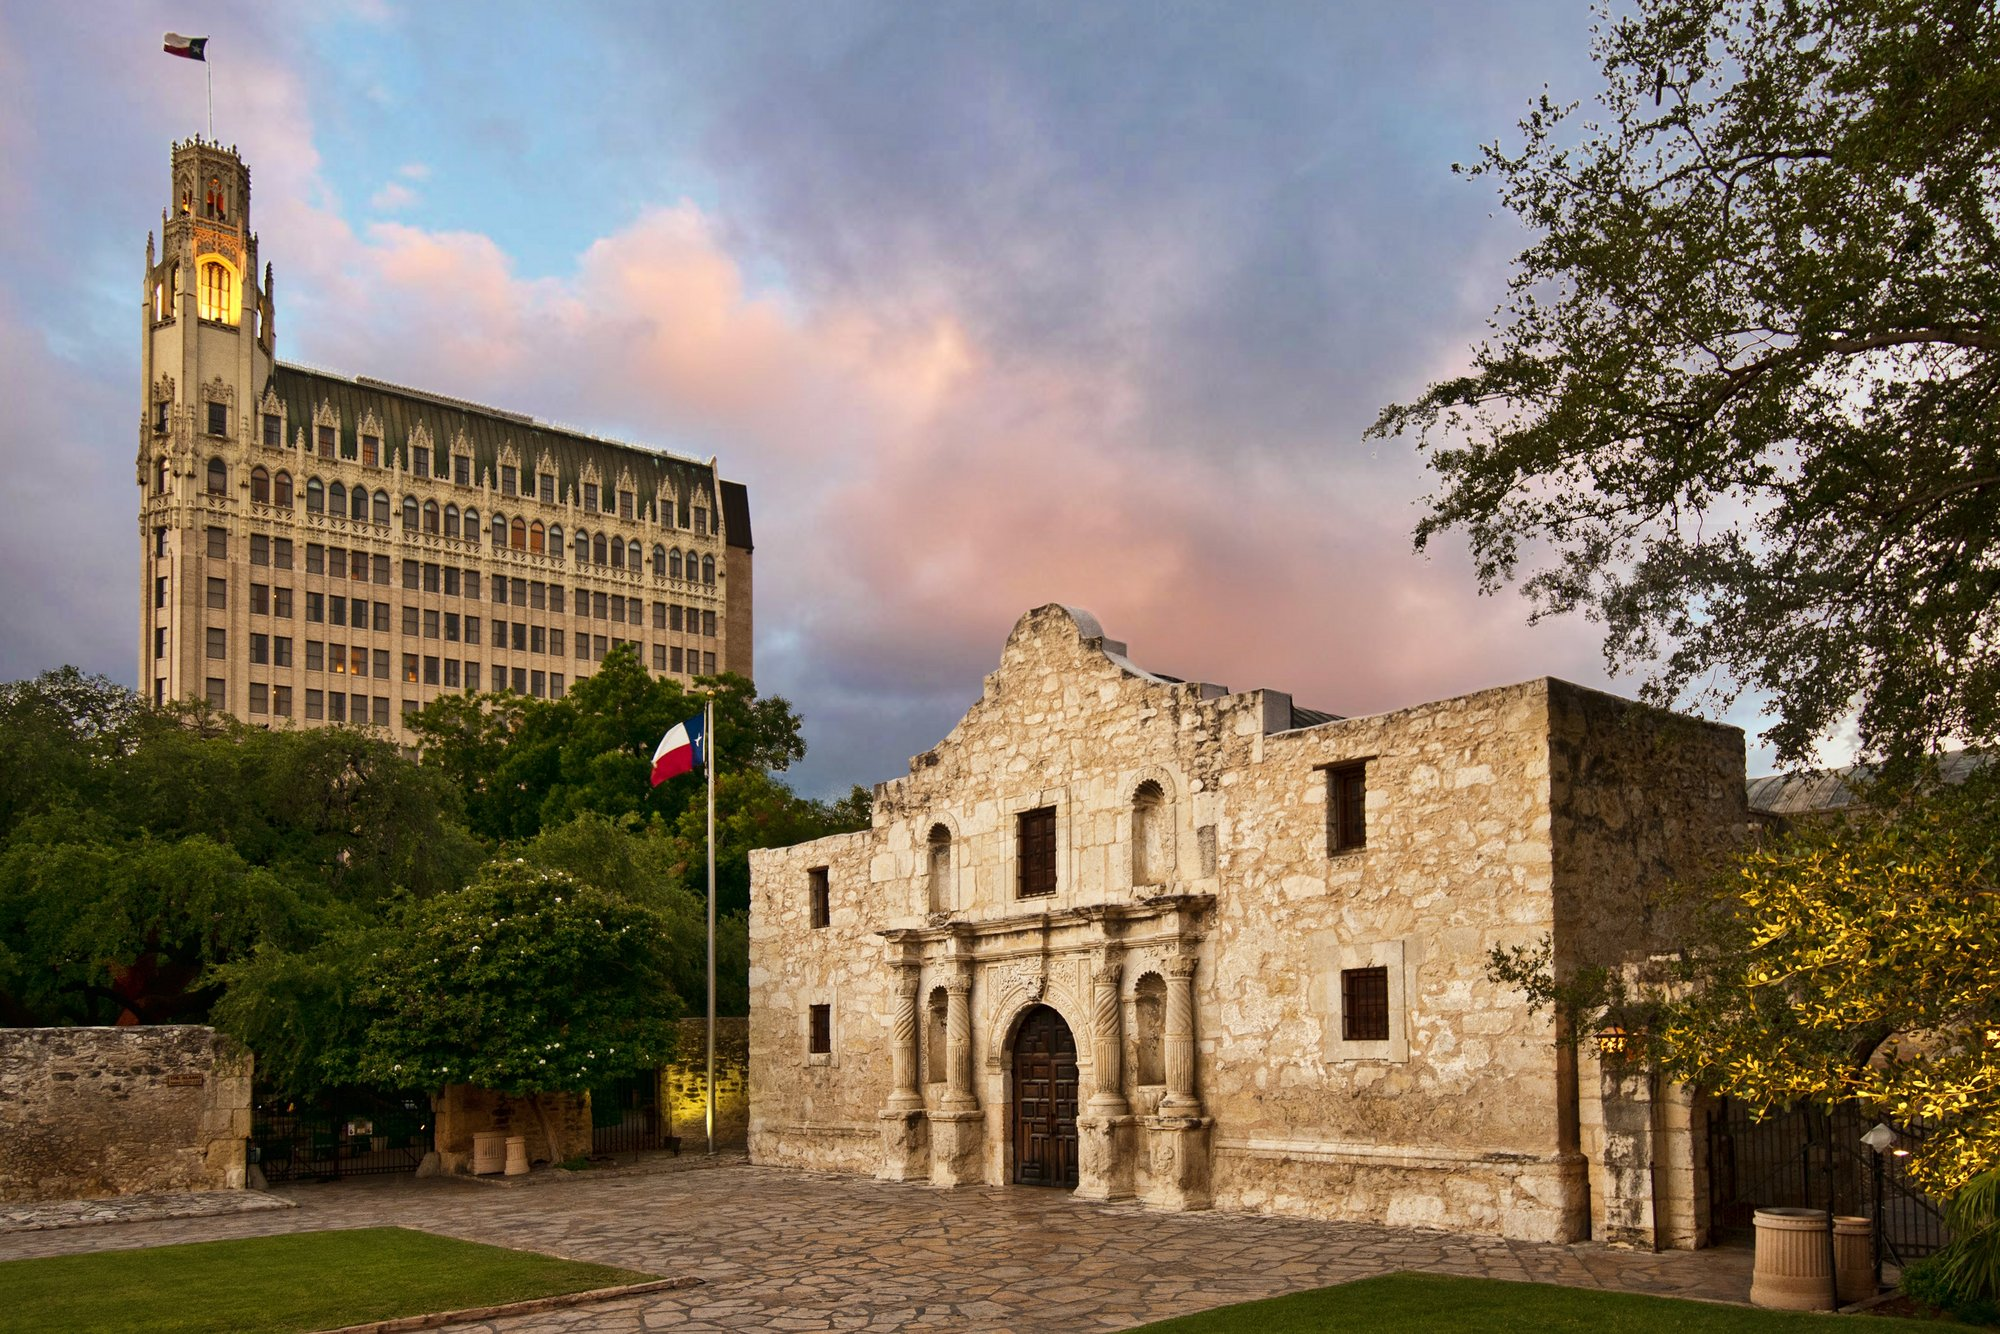Create a futuristic scenario taking place at this location. In the year 2123, the Alamo stands as both a historic relic and a centerpiece of advanced technology preservation. Holographic guides provide interactive tours, projecting lifelike reenactments of the Battle of the Alamo across the site. Visitors can use augmented reality glasses to overlay historical scenes over the present-day view, effectively stepping back into time. Outside, the once simple flagpole now features a smart beacon that not only displays the Texas flag but changes colors to share information about Texan history and culture. Surrounding the Alamo, drones ensure security and maintenance, while solar panels built into the pavement power the entire site. The Alamo and the towering building behind it have both been retrofitted with eco-friendly materials, making them symbols of sustainable progress. As night falls, the sky above the Alamo lights up with drones forming a detailed display commemorating historical events, viewed by visitors who marvel at the blend of past and future. 